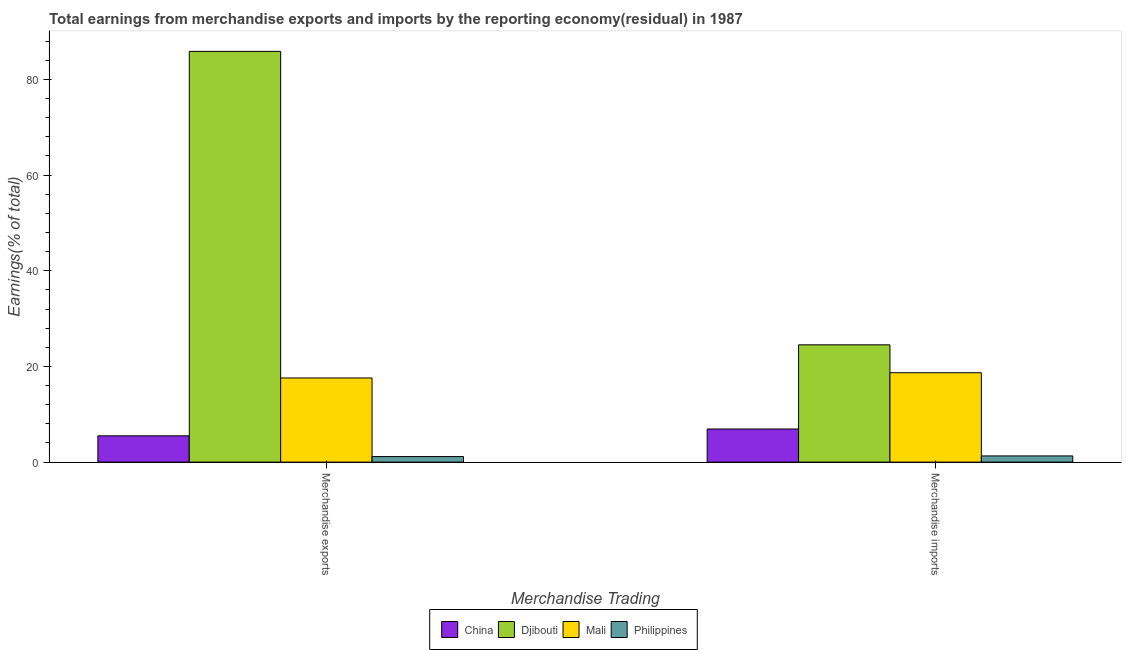How many groups of bars are there?
Offer a very short reply. 2. Are the number of bars per tick equal to the number of legend labels?
Your answer should be compact. Yes. How many bars are there on the 1st tick from the right?
Offer a terse response. 4. What is the label of the 1st group of bars from the left?
Make the answer very short. Merchandise exports. What is the earnings from merchandise imports in Mali?
Your answer should be very brief. 18.68. Across all countries, what is the maximum earnings from merchandise imports?
Your answer should be very brief. 24.51. Across all countries, what is the minimum earnings from merchandise exports?
Your answer should be very brief. 1.16. In which country was the earnings from merchandise exports maximum?
Provide a short and direct response. Djibouti. In which country was the earnings from merchandise exports minimum?
Give a very brief answer. Philippines. What is the total earnings from merchandise imports in the graph?
Give a very brief answer. 51.41. What is the difference between the earnings from merchandise imports in Philippines and that in Mali?
Your answer should be very brief. -17.39. What is the difference between the earnings from merchandise imports in Mali and the earnings from merchandise exports in Djibouti?
Make the answer very short. -67.16. What is the average earnings from merchandise exports per country?
Offer a terse response. 27.52. What is the difference between the earnings from merchandise imports and earnings from merchandise exports in China?
Your response must be concise. 1.43. In how many countries, is the earnings from merchandise exports greater than 48 %?
Offer a terse response. 1. What is the ratio of the earnings from merchandise imports in China to that in Philippines?
Your response must be concise. 5.35. Is the earnings from merchandise exports in China less than that in Djibouti?
Offer a terse response. Yes. In how many countries, is the earnings from merchandise imports greater than the average earnings from merchandise imports taken over all countries?
Make the answer very short. 2. What does the 3rd bar from the left in Merchandise exports represents?
Your answer should be very brief. Mali. What does the 2nd bar from the right in Merchandise exports represents?
Your response must be concise. Mali. How many countries are there in the graph?
Offer a very short reply. 4. What is the difference between two consecutive major ticks on the Y-axis?
Your response must be concise. 20. Are the values on the major ticks of Y-axis written in scientific E-notation?
Give a very brief answer. No. What is the title of the graph?
Your answer should be very brief. Total earnings from merchandise exports and imports by the reporting economy(residual) in 1987. Does "Korea (Republic)" appear as one of the legend labels in the graph?
Offer a very short reply. No. What is the label or title of the X-axis?
Make the answer very short. Merchandise Trading. What is the label or title of the Y-axis?
Provide a succinct answer. Earnings(% of total). What is the Earnings(% of total) of China in Merchandise exports?
Provide a succinct answer. 5.49. What is the Earnings(% of total) of Djibouti in Merchandise exports?
Keep it short and to the point. 85.85. What is the Earnings(% of total) of Mali in Merchandise exports?
Keep it short and to the point. 17.59. What is the Earnings(% of total) in Philippines in Merchandise exports?
Provide a succinct answer. 1.16. What is the Earnings(% of total) in China in Merchandise imports?
Ensure brevity in your answer.  6.92. What is the Earnings(% of total) in Djibouti in Merchandise imports?
Your response must be concise. 24.51. What is the Earnings(% of total) in Mali in Merchandise imports?
Your answer should be very brief. 18.68. What is the Earnings(% of total) in Philippines in Merchandise imports?
Your answer should be very brief. 1.29. Across all Merchandise Trading, what is the maximum Earnings(% of total) of China?
Offer a terse response. 6.92. Across all Merchandise Trading, what is the maximum Earnings(% of total) in Djibouti?
Keep it short and to the point. 85.85. Across all Merchandise Trading, what is the maximum Earnings(% of total) in Mali?
Your response must be concise. 18.68. Across all Merchandise Trading, what is the maximum Earnings(% of total) in Philippines?
Provide a short and direct response. 1.29. Across all Merchandise Trading, what is the minimum Earnings(% of total) of China?
Your response must be concise. 5.49. Across all Merchandise Trading, what is the minimum Earnings(% of total) of Djibouti?
Offer a very short reply. 24.51. Across all Merchandise Trading, what is the minimum Earnings(% of total) of Mali?
Your response must be concise. 17.59. Across all Merchandise Trading, what is the minimum Earnings(% of total) in Philippines?
Your answer should be compact. 1.16. What is the total Earnings(% of total) of China in the graph?
Provide a succinct answer. 12.42. What is the total Earnings(% of total) in Djibouti in the graph?
Keep it short and to the point. 110.36. What is the total Earnings(% of total) of Mali in the graph?
Your response must be concise. 36.27. What is the total Earnings(% of total) in Philippines in the graph?
Offer a terse response. 2.46. What is the difference between the Earnings(% of total) of China in Merchandise exports and that in Merchandise imports?
Your answer should be compact. -1.43. What is the difference between the Earnings(% of total) of Djibouti in Merchandise exports and that in Merchandise imports?
Provide a short and direct response. 61.33. What is the difference between the Earnings(% of total) of Mali in Merchandise exports and that in Merchandise imports?
Your answer should be compact. -1.1. What is the difference between the Earnings(% of total) in Philippines in Merchandise exports and that in Merchandise imports?
Keep it short and to the point. -0.13. What is the difference between the Earnings(% of total) in China in Merchandise exports and the Earnings(% of total) in Djibouti in Merchandise imports?
Give a very brief answer. -19.02. What is the difference between the Earnings(% of total) of China in Merchandise exports and the Earnings(% of total) of Mali in Merchandise imports?
Ensure brevity in your answer.  -13.19. What is the difference between the Earnings(% of total) of China in Merchandise exports and the Earnings(% of total) of Philippines in Merchandise imports?
Provide a short and direct response. 4.2. What is the difference between the Earnings(% of total) in Djibouti in Merchandise exports and the Earnings(% of total) in Mali in Merchandise imports?
Provide a short and direct response. 67.16. What is the difference between the Earnings(% of total) of Djibouti in Merchandise exports and the Earnings(% of total) of Philippines in Merchandise imports?
Your answer should be very brief. 84.55. What is the difference between the Earnings(% of total) of Mali in Merchandise exports and the Earnings(% of total) of Philippines in Merchandise imports?
Keep it short and to the point. 16.29. What is the average Earnings(% of total) in China per Merchandise Trading?
Your answer should be compact. 6.21. What is the average Earnings(% of total) of Djibouti per Merchandise Trading?
Your answer should be compact. 55.18. What is the average Earnings(% of total) of Mali per Merchandise Trading?
Provide a short and direct response. 18.13. What is the average Earnings(% of total) in Philippines per Merchandise Trading?
Provide a succinct answer. 1.23. What is the difference between the Earnings(% of total) in China and Earnings(% of total) in Djibouti in Merchandise exports?
Your answer should be compact. -80.35. What is the difference between the Earnings(% of total) in China and Earnings(% of total) in Mali in Merchandise exports?
Offer a very short reply. -12.09. What is the difference between the Earnings(% of total) in China and Earnings(% of total) in Philippines in Merchandise exports?
Provide a short and direct response. 4.33. What is the difference between the Earnings(% of total) in Djibouti and Earnings(% of total) in Mali in Merchandise exports?
Ensure brevity in your answer.  68.26. What is the difference between the Earnings(% of total) in Djibouti and Earnings(% of total) in Philippines in Merchandise exports?
Offer a very short reply. 84.69. What is the difference between the Earnings(% of total) in Mali and Earnings(% of total) in Philippines in Merchandise exports?
Keep it short and to the point. 16.42. What is the difference between the Earnings(% of total) in China and Earnings(% of total) in Djibouti in Merchandise imports?
Provide a short and direct response. -17.59. What is the difference between the Earnings(% of total) of China and Earnings(% of total) of Mali in Merchandise imports?
Offer a terse response. -11.76. What is the difference between the Earnings(% of total) in China and Earnings(% of total) in Philippines in Merchandise imports?
Ensure brevity in your answer.  5.63. What is the difference between the Earnings(% of total) in Djibouti and Earnings(% of total) in Mali in Merchandise imports?
Make the answer very short. 5.83. What is the difference between the Earnings(% of total) of Djibouti and Earnings(% of total) of Philippines in Merchandise imports?
Offer a very short reply. 23.22. What is the difference between the Earnings(% of total) in Mali and Earnings(% of total) in Philippines in Merchandise imports?
Provide a succinct answer. 17.39. What is the ratio of the Earnings(% of total) in China in Merchandise exports to that in Merchandise imports?
Your answer should be compact. 0.79. What is the ratio of the Earnings(% of total) of Djibouti in Merchandise exports to that in Merchandise imports?
Make the answer very short. 3.5. What is the ratio of the Earnings(% of total) in Mali in Merchandise exports to that in Merchandise imports?
Your response must be concise. 0.94. What is the ratio of the Earnings(% of total) in Philippines in Merchandise exports to that in Merchandise imports?
Give a very brief answer. 0.9. What is the difference between the highest and the second highest Earnings(% of total) in China?
Provide a short and direct response. 1.43. What is the difference between the highest and the second highest Earnings(% of total) of Djibouti?
Your answer should be very brief. 61.33. What is the difference between the highest and the second highest Earnings(% of total) in Mali?
Ensure brevity in your answer.  1.1. What is the difference between the highest and the second highest Earnings(% of total) in Philippines?
Your answer should be very brief. 0.13. What is the difference between the highest and the lowest Earnings(% of total) in China?
Offer a terse response. 1.43. What is the difference between the highest and the lowest Earnings(% of total) of Djibouti?
Give a very brief answer. 61.33. What is the difference between the highest and the lowest Earnings(% of total) of Mali?
Your answer should be very brief. 1.1. What is the difference between the highest and the lowest Earnings(% of total) of Philippines?
Make the answer very short. 0.13. 